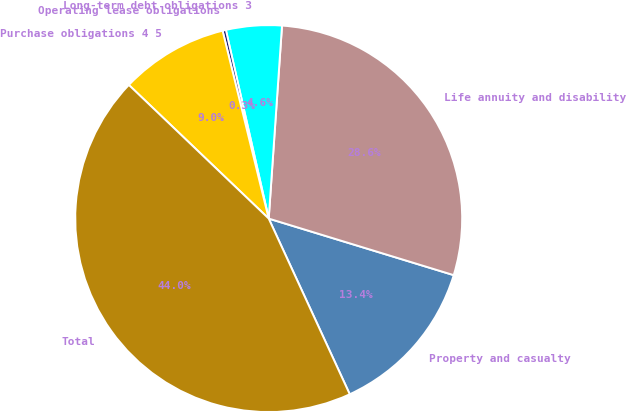<chart> <loc_0><loc_0><loc_500><loc_500><pie_chart><fcel>Property and casualty<fcel>Life annuity and disability<fcel>Long-term debt obligations 3<fcel>Operating lease obligations<fcel>Purchase obligations 4 5<fcel>Total<nl><fcel>13.4%<fcel>28.63%<fcel>4.65%<fcel>0.28%<fcel>9.03%<fcel>44.02%<nl></chart> 